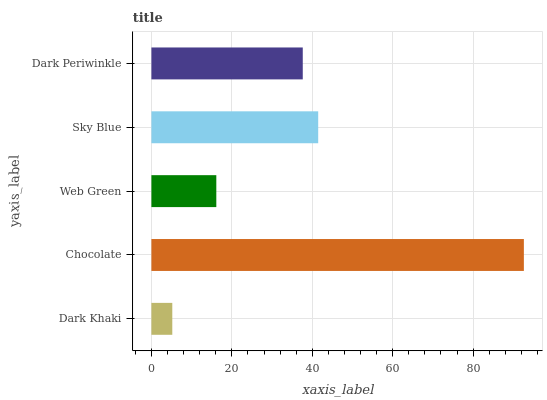Is Dark Khaki the minimum?
Answer yes or no. Yes. Is Chocolate the maximum?
Answer yes or no. Yes. Is Web Green the minimum?
Answer yes or no. No. Is Web Green the maximum?
Answer yes or no. No. Is Chocolate greater than Web Green?
Answer yes or no. Yes. Is Web Green less than Chocolate?
Answer yes or no. Yes. Is Web Green greater than Chocolate?
Answer yes or no. No. Is Chocolate less than Web Green?
Answer yes or no. No. Is Dark Periwinkle the high median?
Answer yes or no. Yes. Is Dark Periwinkle the low median?
Answer yes or no. Yes. Is Chocolate the high median?
Answer yes or no. No. Is Web Green the low median?
Answer yes or no. No. 